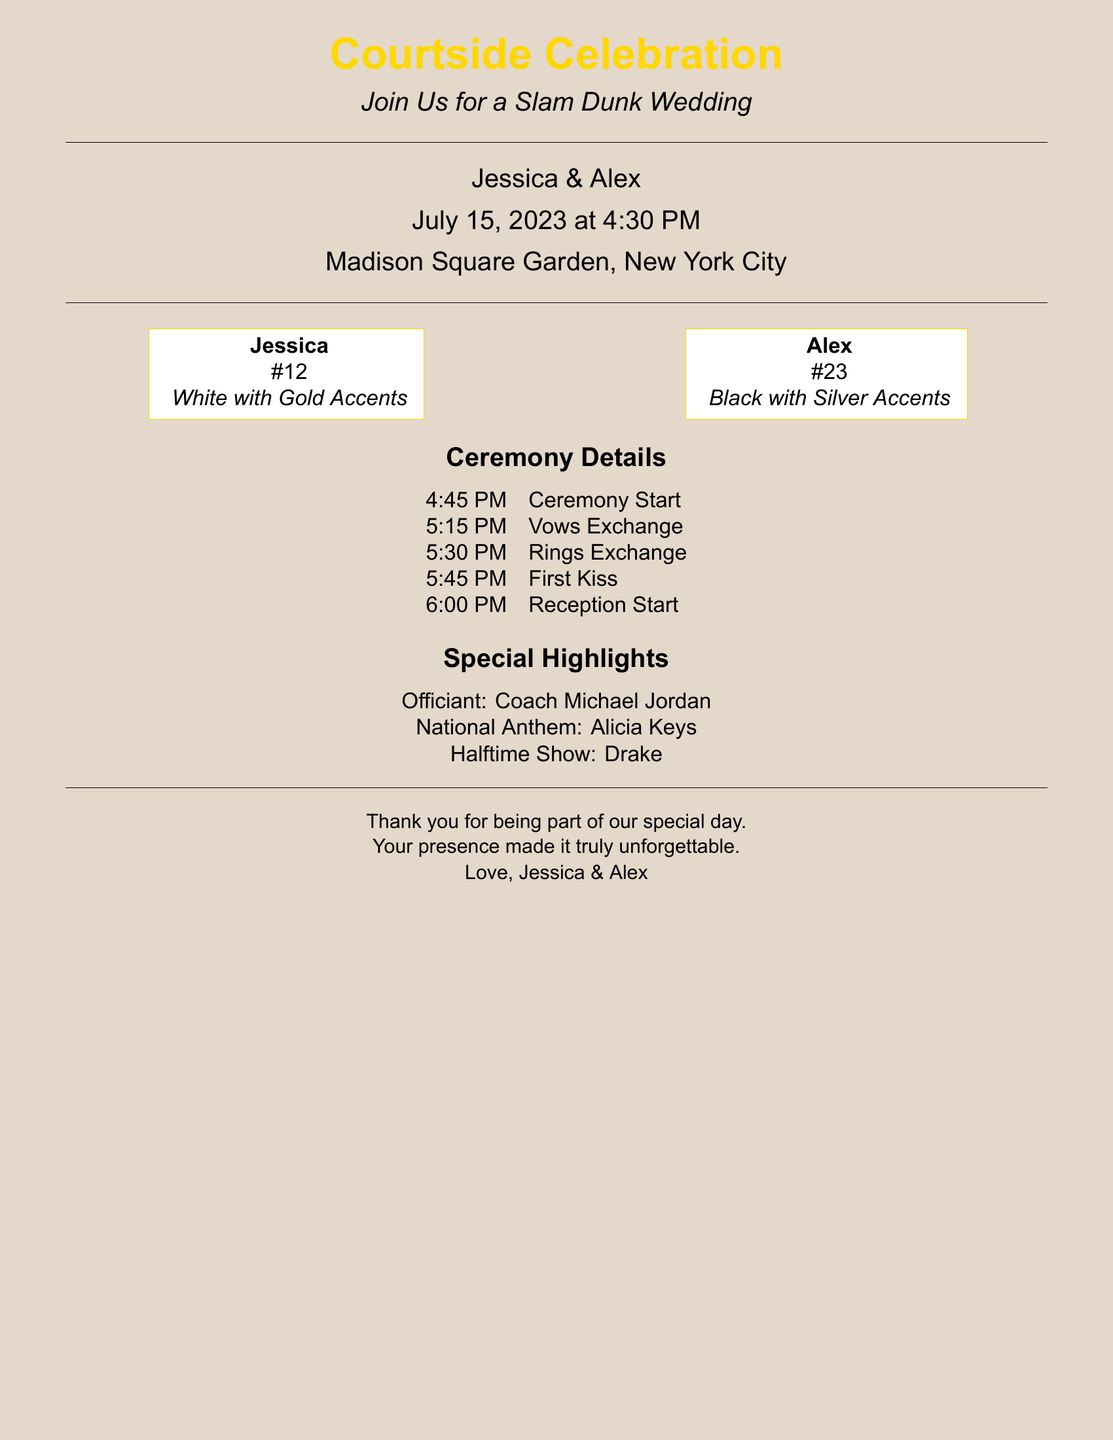What is the name of the couple? The names of the couple are prominently displayed in the invitation.
Answer: Jessica & Alex What is the wedding date? The date of the wedding is mentioned clearly in the document.
Answer: July 15, 2023 What time does the ceremony start? The time the ceremony begins is specifically listed in the schedule.
Answer: 4:45 PM Who is the officiant? The officiant's name is given in the special highlights section.
Answer: Coach Michael Jordan What is the venue for the wedding? The location where the celebration will take place is stated in the invitation.
Answer: Madison Square Garden, New York City Which artist will perform the national anthem? The performer for the national anthem is featured among the special highlights.
Answer: Alicia Keys What jersey number will Jessica wear? Jessica's jersey number is mentioned on the left side of the invitation.
Answer: #12 What color accents will Alex's jersey have? The color details for Alex's jersey are specified in the invitation.
Answer: Silver Accents What is included in the personalized thank-you notes? The thank-you notes express appreciation to the guests for their presence.
Answer: Your presence made it truly unforgettable 